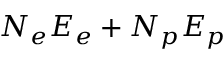<formula> <loc_0><loc_0><loc_500><loc_500>N _ { e } E _ { e } + N _ { p } E _ { p }</formula> 